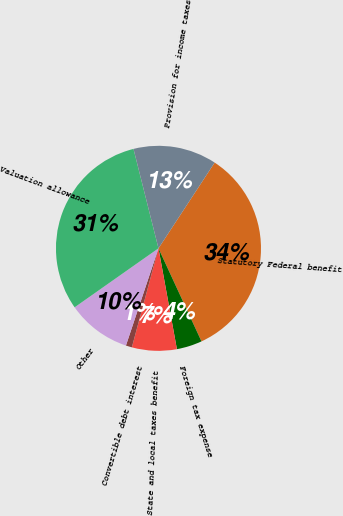Convert chart. <chart><loc_0><loc_0><loc_500><loc_500><pie_chart><fcel>Statutory Federal benefit<fcel>Foreign tax expense<fcel>State and local taxes benefit<fcel>Convertible debt interest<fcel>Other<fcel>Valuation allowance<fcel>Provision for income taxes<nl><fcel>33.88%<fcel>4.01%<fcel>7.06%<fcel>0.96%<fcel>10.1%<fcel>30.84%<fcel>13.15%<nl></chart> 